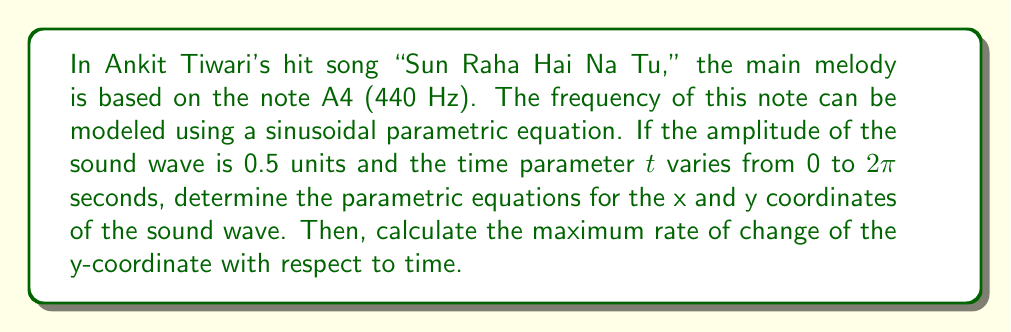What is the answer to this math problem? Let's approach this step-by-step:

1) The general form of parametric equations for a sine wave is:
   $x = at$
   $y = A\sin(bt)$
   
   Where $a$ is the speed of the wave along the x-axis, $A$ is the amplitude, and $b$ is related to the frequency.

2) We're given that the amplitude $A = 0.5$ units.

3) For frequency, we use the note A4 which is 440 Hz. This means the wave completes 440 cycles per second.

4) Since $t$ varies from 0 to $2\pi$ seconds for one complete cycle, we can set up the equation:
   $440 = \frac{b}{2\pi}$
   $b = 440 * 2\pi = 880\pi$

5) For simplicity, let's set $a = 1$, meaning the wave travels at 1 unit per second along the x-axis.

6) Now we can write our parametric equations:
   $x = t$
   $y = 0.5\sin(880\pi t)$

7) To find the maximum rate of change of y with respect to time, we need to find the maximum value of $\frac{dy}{dt}$.

8) $\frac{dy}{dt} = 0.5 * 880\pi * \cos(880\pi t) = 440\pi\cos(880\pi t)$

9) The maximum value of cosine is 1, so the maximum rate of change is:
   $\left|\frac{dy}{dt}\right|_{max} = 440\pi \approx 1382.3$ units/second
Answer: The parametric equations are:
$x = t$
$y = 0.5\sin(880\pi t)$

The maximum rate of change of the y-coordinate with respect to time is $440\pi \approx 1382.3$ units/second. 